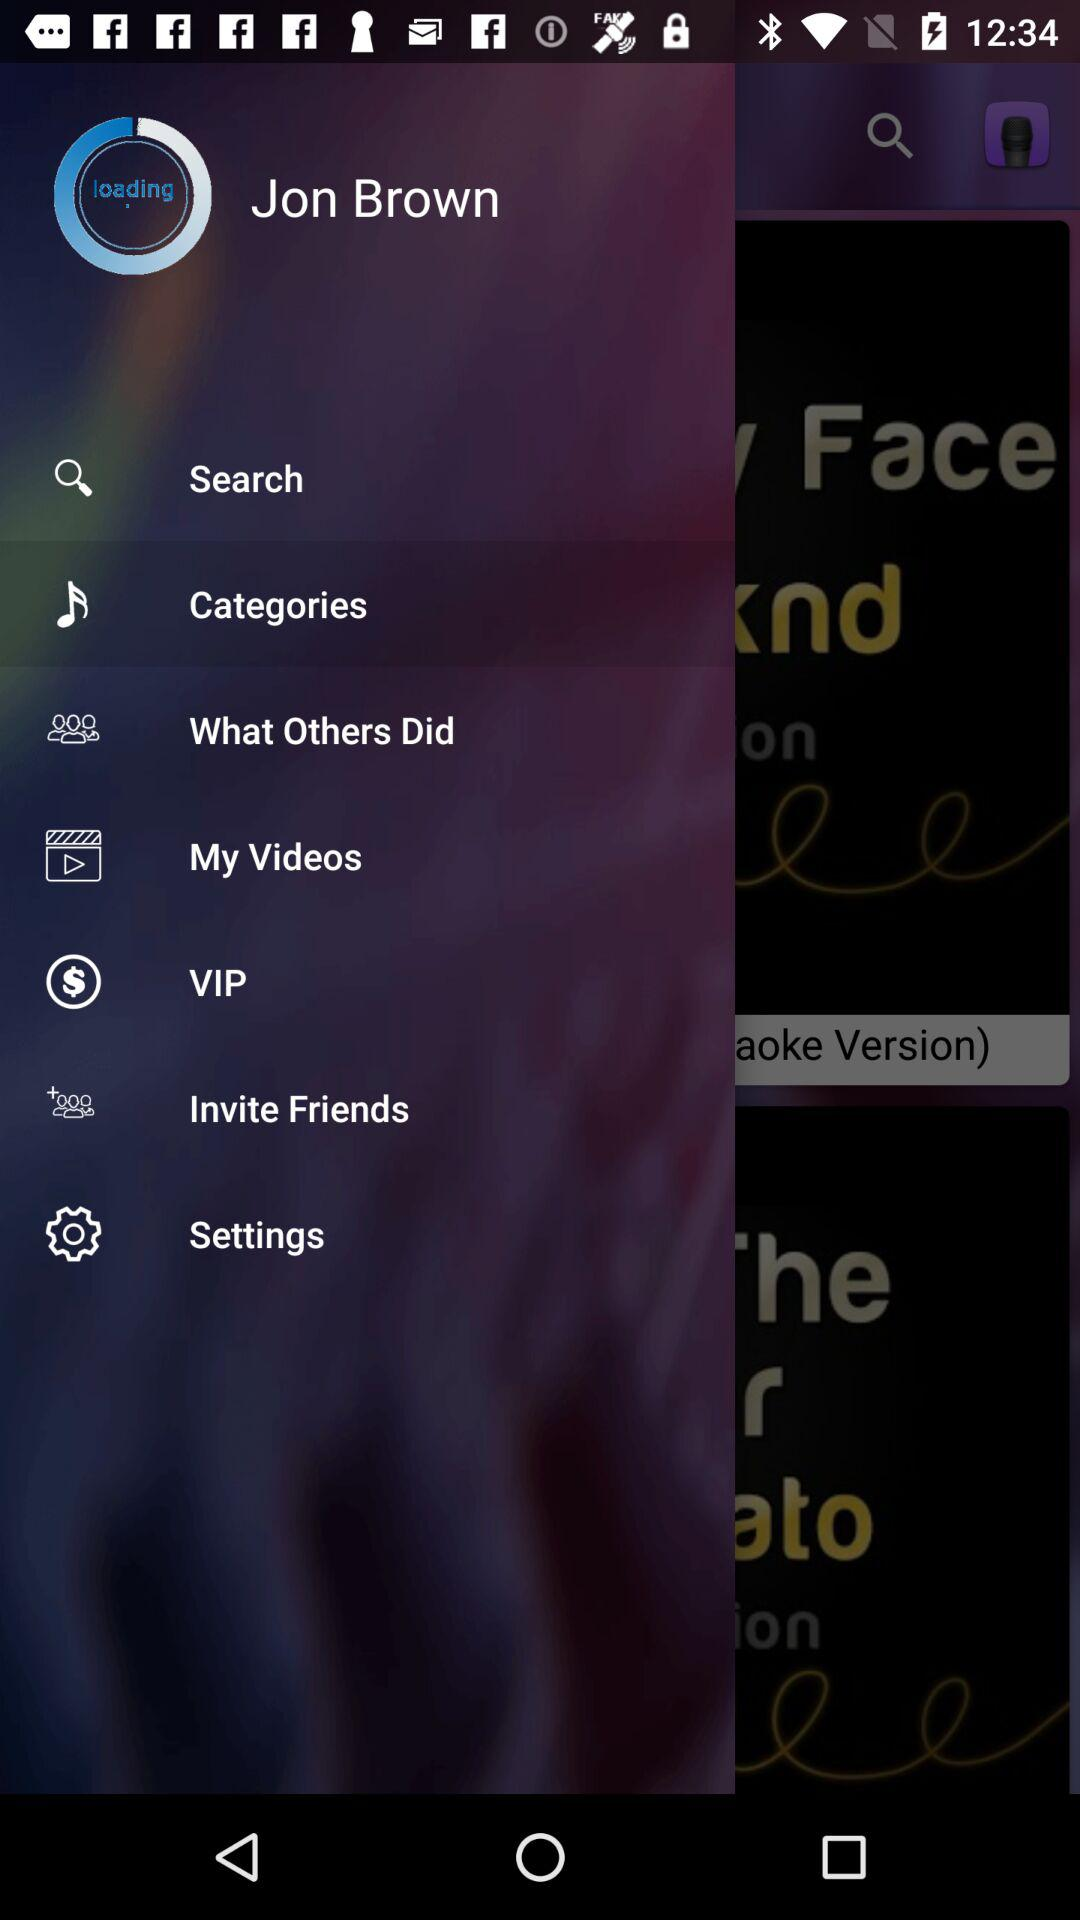What is the selected item? The selected item is "Categories". 